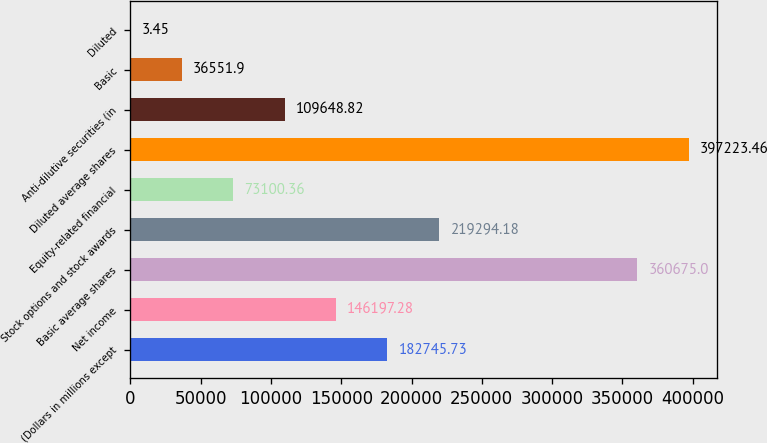Convert chart. <chart><loc_0><loc_0><loc_500><loc_500><bar_chart><fcel>(Dollars in millions except<fcel>Net income<fcel>Basic average shares<fcel>Stock options and stock awards<fcel>Equity-related financial<fcel>Diluted average shares<fcel>Anti-dilutive securities (in<fcel>Basic<fcel>Diluted<nl><fcel>182746<fcel>146197<fcel>360675<fcel>219294<fcel>73100.4<fcel>397223<fcel>109649<fcel>36551.9<fcel>3.45<nl></chart> 